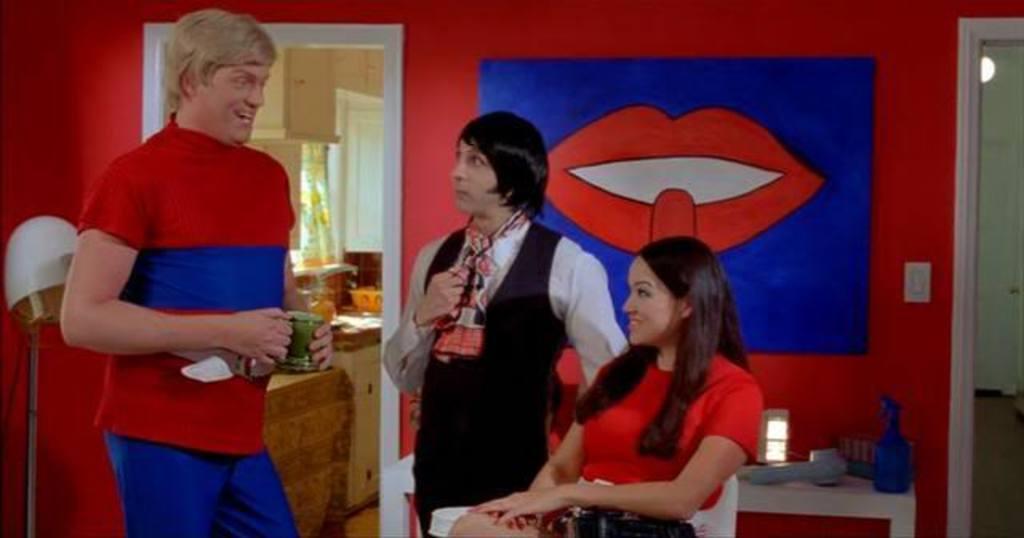Describe this image in one or two sentences. In this image, we can see a woman sitting and there are two persons standing and we can see the wall and there is a photo on the wall and we can see the door. 